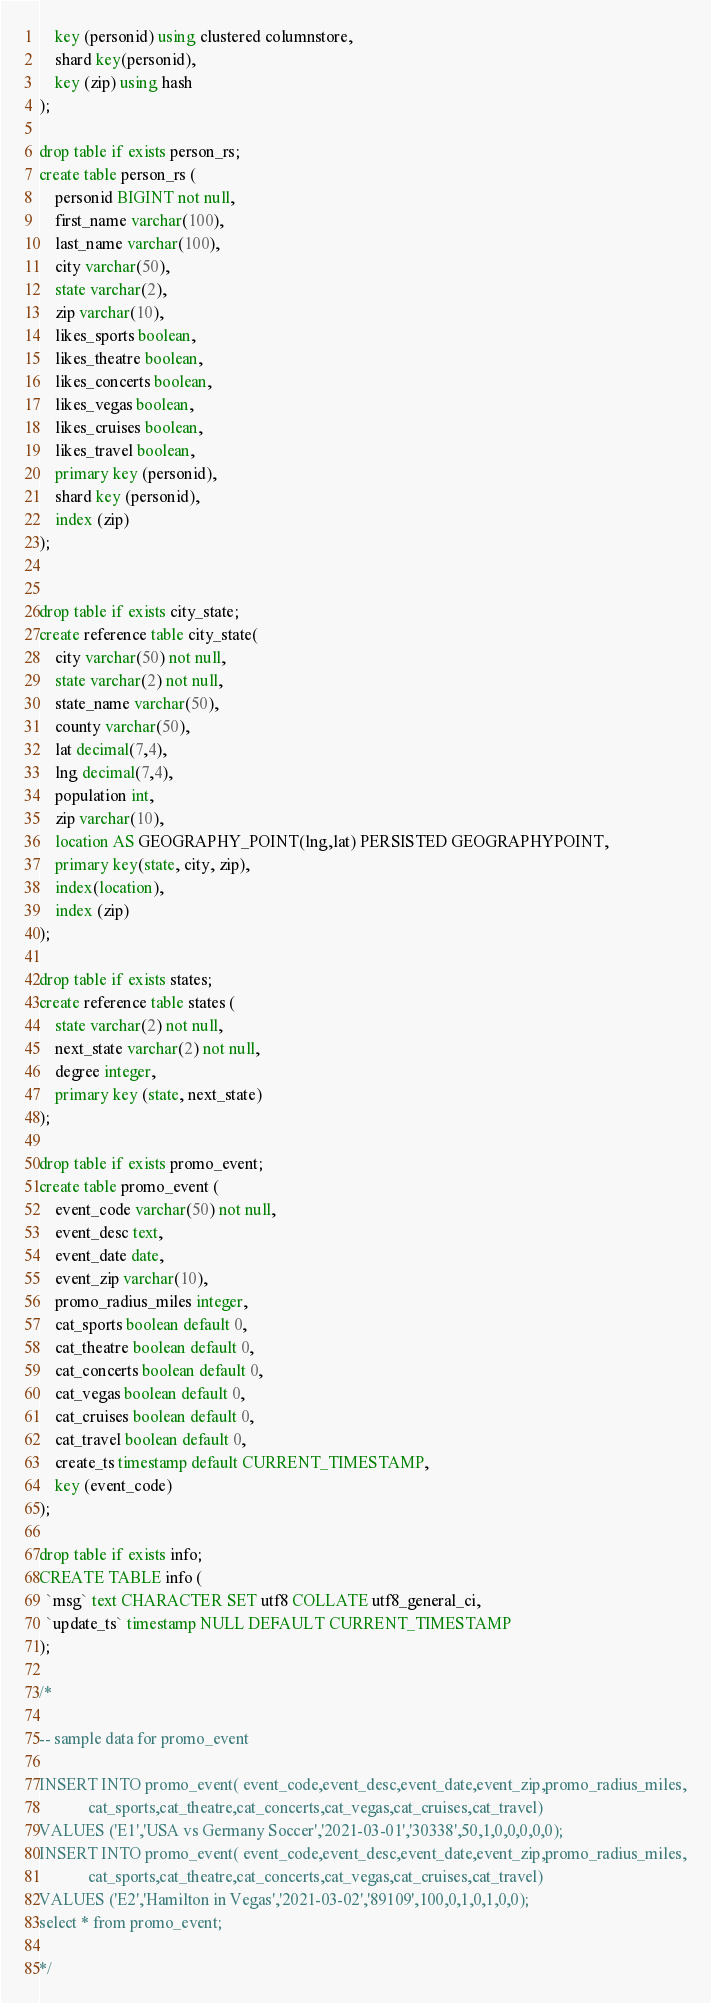<code> <loc_0><loc_0><loc_500><loc_500><_SQL_>    key (personid) using clustered columnstore,
    shard key(personid),
    key (zip) using hash
);

drop table if exists person_rs;
create table person_rs (
    personid BIGINT not null,
    first_name varchar(100),
    last_name varchar(100),
    city varchar(50),
    state varchar(2),
    zip varchar(10),
    likes_sports boolean,
    likes_theatre boolean,
    likes_concerts boolean,
    likes_vegas boolean,
    likes_cruises boolean,
    likes_travel boolean,
    primary key (personid),
    shard key (personid),
    index (zip) 
);


drop table if exists city_state;
create reference table city_state(
    city varchar(50) not null,
    state varchar(2) not null,
    state_name varchar(50),
    county varchar(50),
    lat decimal(7,4),
    lng decimal(7,4),
    population int,
    zip varchar(10),
    location AS GEOGRAPHY_POINT(lng,lat) PERSISTED GEOGRAPHYPOINT,
    primary key(state, city, zip),
    index(location),
    index (zip)
);

drop table if exists states;
create reference table states (
    state varchar(2) not null,
    next_state varchar(2) not null,
    degree integer,
    primary key (state, next_state)
);

drop table if exists promo_event;
create table promo_event (
    event_code varchar(50) not null,
    event_desc text,
    event_date date,
    event_zip varchar(10),
    promo_radius_miles integer,
    cat_sports boolean default 0,
    cat_theatre boolean default 0,
    cat_concerts boolean default 0,
    cat_vegas boolean default 0,
    cat_cruises boolean default 0,
    cat_travel boolean default 0,
    create_ts timestamp default CURRENT_TIMESTAMP,
    key (event_code)
);

drop table if exists info;
CREATE TABLE info (
  `msg` text CHARACTER SET utf8 COLLATE utf8_general_ci,
  `update_ts` timestamp NULL DEFAULT CURRENT_TIMESTAMP
);

/*

-- sample data for promo_event

INSERT INTO promo_event( event_code,event_desc,event_date,event_zip,promo_radius_miles,
            cat_sports,cat_theatre,cat_concerts,cat_vegas,cat_cruises,cat_travel)
VALUES ('E1','USA vs Germany Soccer','2021-03-01','30338',50,1,0,0,0,0,0);
INSERT INTO promo_event( event_code,event_desc,event_date,event_zip,promo_radius_miles,
            cat_sports,cat_theatre,cat_concerts,cat_vegas,cat_cruises,cat_travel)
VALUES ('E2','Hamilton in Vegas','2021-03-02','89109',100,0,1,0,1,0,0);
select * from promo_event;

*/


</code> 